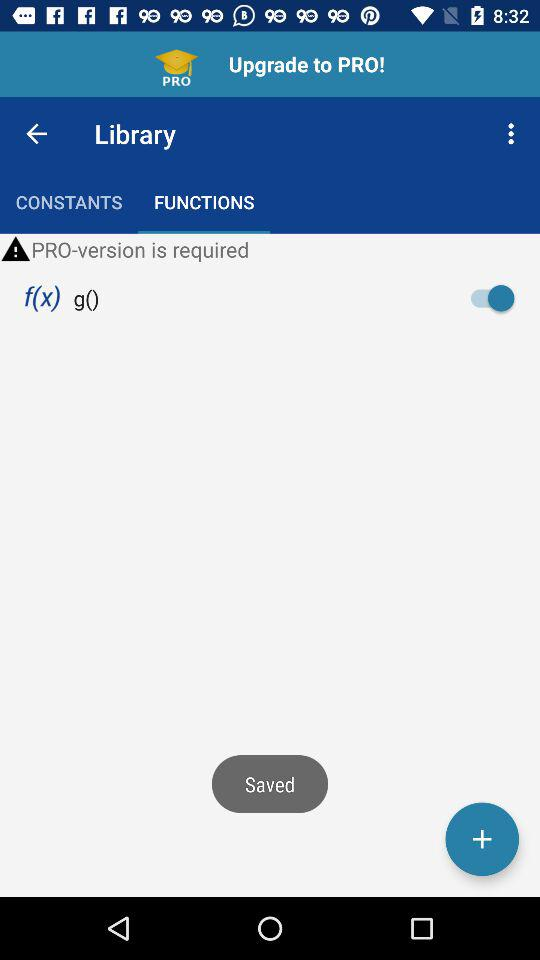What is the status of "f(x) g()"? The status is "on". 